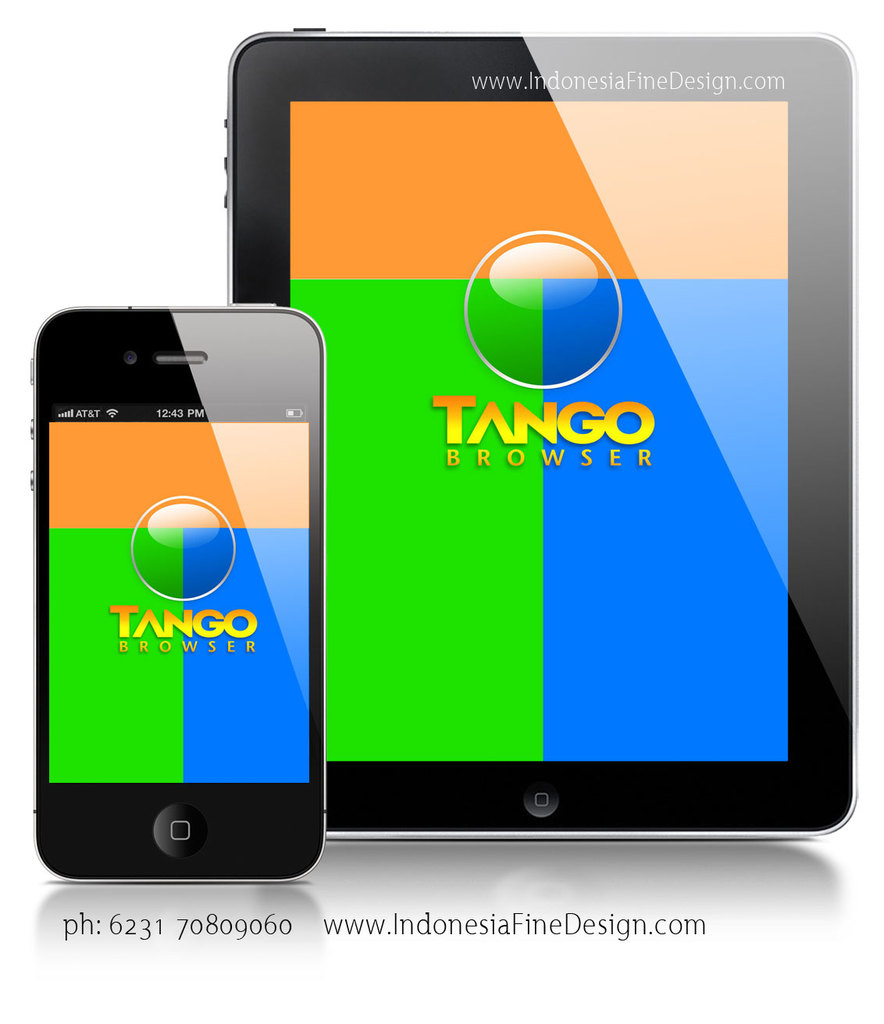Provide a one-sentence caption for the provided image. The image illustrates a dynamic display of the Tango Browser, which is viewed on both a smartphone and a tablet, highlighting the app's vibrant, user-friendly interface designed for various device sizes. 